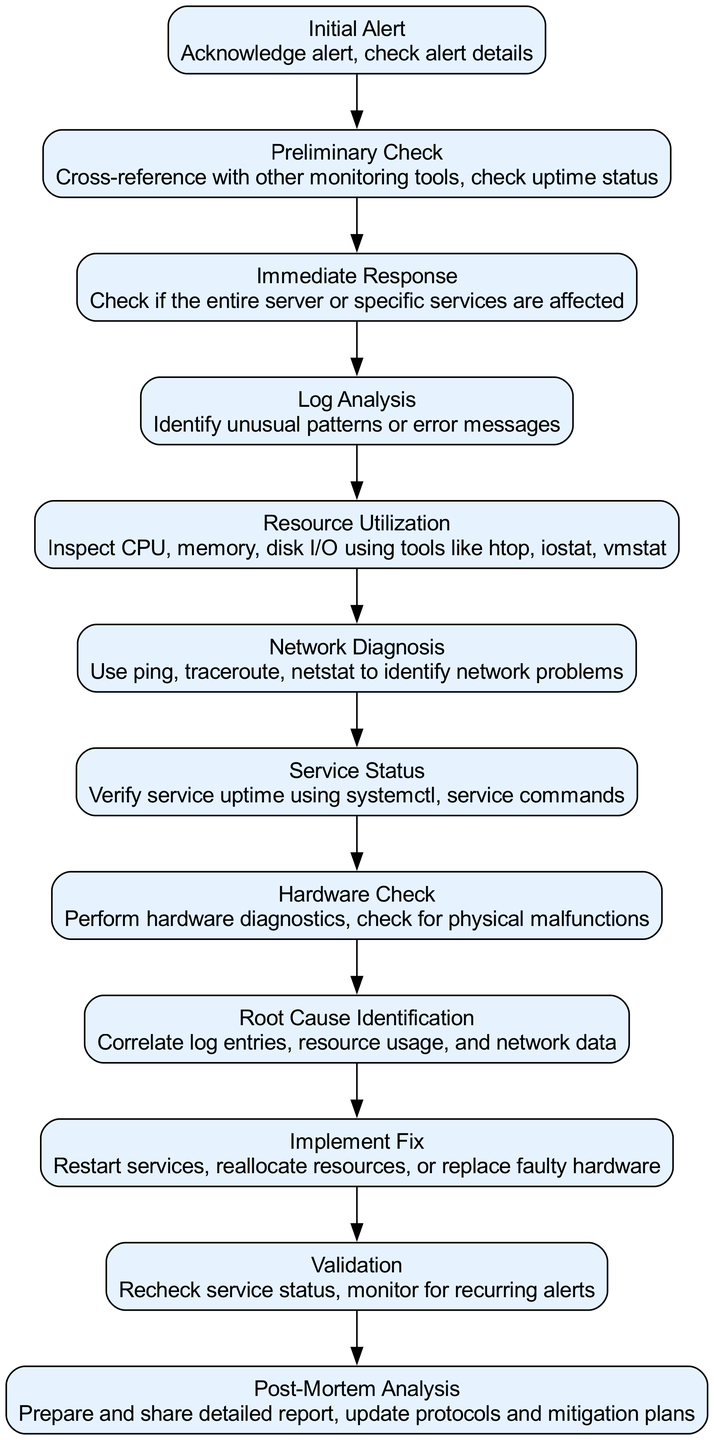What is the first step in the pathway? The first step in the pathway is labeled as "Initial Alert," which indicates that the process begins when an alert is received from a monitoring tool.
Answer: Initial Alert How many steps are included in the troubleshooting pathway? The diagram includes a total of 12 steps, starting from "Initial Alert" to "Post-Mortem Analysis."
Answer: 12 What action is taken in the "Log Analysis" step? The action taken in the "Log Analysis" step is to analyze system logs to identify unusual patterns or error messages, helping diagnose the issue at hand.
Answer: Identify unusual patterns or error messages Which step follows "Network Diagnosis"? The step that follows "Network Diagnosis" is "Service Status," indicating that after evaluating network issues, the status of critical services should be checked.
Answer: Service Status What primary activity occurs in the "Implement Fix" step? In the "Implement Fix" step, the main activity involves applying corrective measures such as restarting services or reallocating resources to resolve the identified issue.
Answer: Apply corrective measures What does "Post-Mortem Analysis" entail? The "Post-Mortem Analysis" entails documenting the downtime incident and preparing a detailed report that is shared and used to update protocols and mitigation plans.
Answer: Document downtime incident Which two steps focus on analyzing system performance? The steps that focus on analyzing system performance are "Log Analysis," which looks at system logs, and "Resource Utilization," which inspects CPU, memory, and disk I/O usage.
Answer: Log Analysis and Resource Utilization What is the purpose of the "Validation" step? The purpose of the "Validation" step is to confirm that the problem is resolved by rechecking service status and monitoring for any recurring alerts.
Answer: Confirm problem resolution In which step are hardware issues addressed? Hardware issues are addressed in the "Hardware Check" step, where physical server health is inspected and hardware diagnostics are performed.
Answer: Hardware Check What should be done during the "Immediate Response" step? During the "Immediate Response" step, it is important to assess whether the issue is ongoing and check if the entire server or specific services are affected.
Answer: Assess if it's an ongoing critical issue 